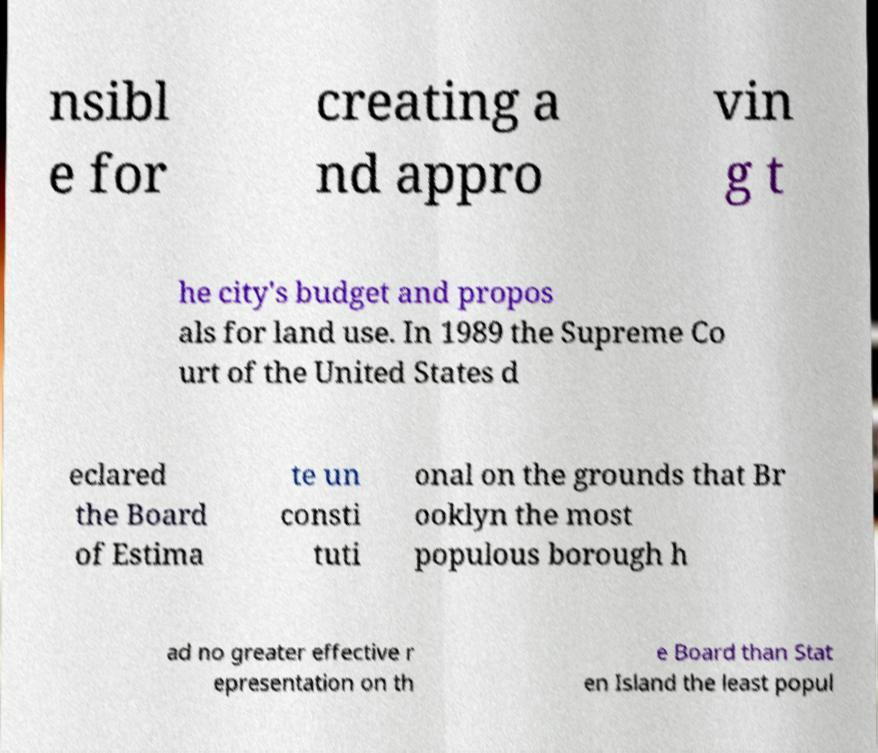Can you read and provide the text displayed in the image?This photo seems to have some interesting text. Can you extract and type it out for me? nsibl e for creating a nd appro vin g t he city's budget and propos als for land use. In 1989 the Supreme Co urt of the United States d eclared the Board of Estima te un consti tuti onal on the grounds that Br ooklyn the most populous borough h ad no greater effective r epresentation on th e Board than Stat en Island the least popul 